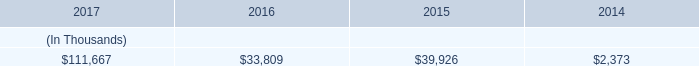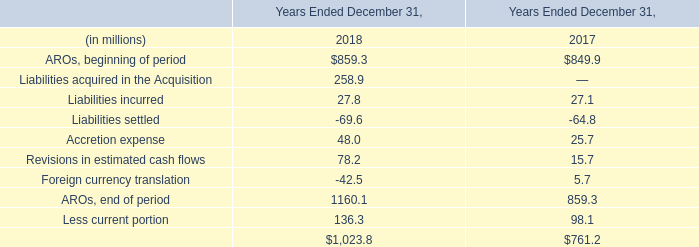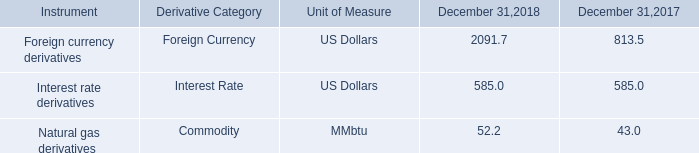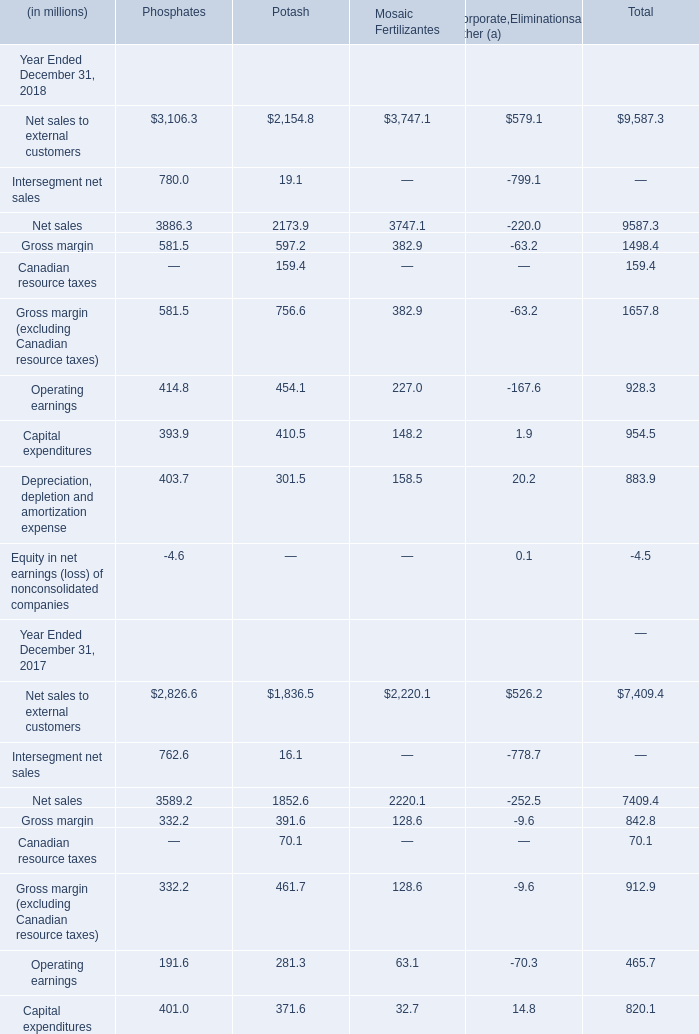What's the average of AROs, end of period of Years Ended December 31, 2018, and Net sales of Phosphates ? 
Computations: ((1160.1 + 3886.3) / 2)
Answer: 2523.2. 